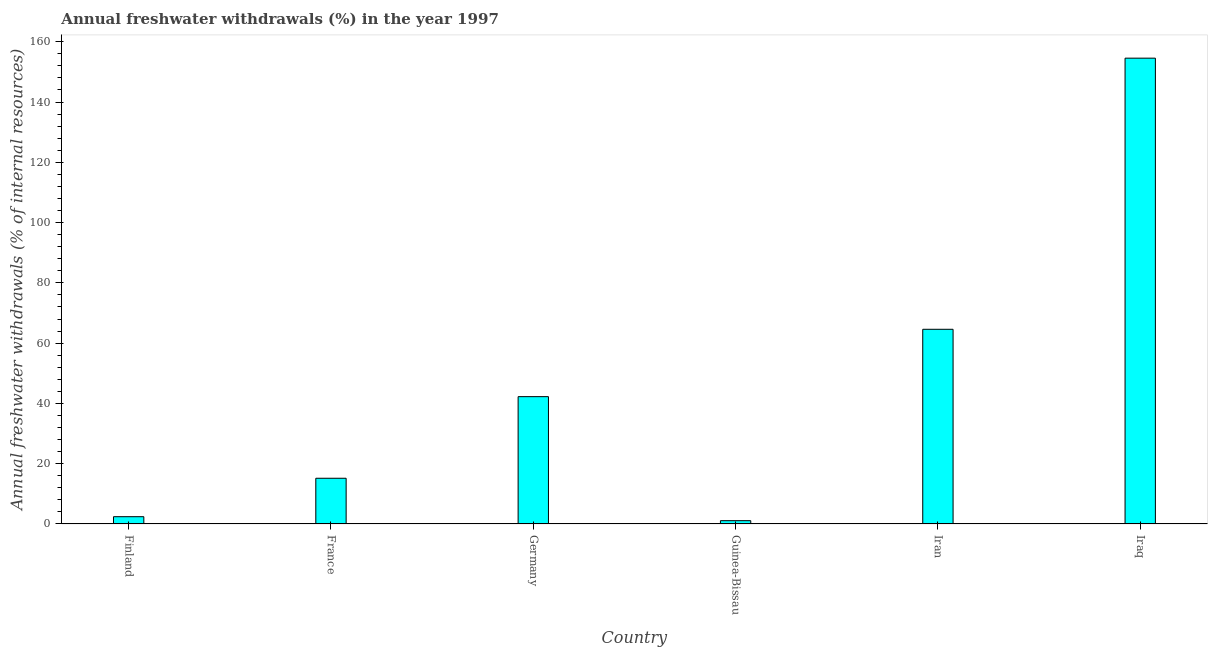Does the graph contain any zero values?
Your answer should be compact. No. Does the graph contain grids?
Provide a succinct answer. No. What is the title of the graph?
Make the answer very short. Annual freshwater withdrawals (%) in the year 1997. What is the label or title of the Y-axis?
Your answer should be compact. Annual freshwater withdrawals (% of internal resources). What is the annual freshwater withdrawals in France?
Provide a short and direct response. 15.17. Across all countries, what is the maximum annual freshwater withdrawals?
Make the answer very short. 154.55. Across all countries, what is the minimum annual freshwater withdrawals?
Ensure brevity in your answer.  1.09. In which country was the annual freshwater withdrawals maximum?
Offer a very short reply. Iraq. In which country was the annual freshwater withdrawals minimum?
Ensure brevity in your answer.  Guinea-Bissau. What is the sum of the annual freshwater withdrawals?
Provide a short and direct response. 280.06. What is the difference between the annual freshwater withdrawals in France and Guinea-Bissau?
Make the answer very short. 14.08. What is the average annual freshwater withdrawals per country?
Your answer should be compact. 46.68. What is the median annual freshwater withdrawals?
Offer a very short reply. 28.71. What is the ratio of the annual freshwater withdrawals in Finland to that in Iran?
Provide a succinct answer. 0.04. Is the difference between the annual freshwater withdrawals in Germany and Guinea-Bissau greater than the difference between any two countries?
Your answer should be compact. No. What is the difference between the highest and the second highest annual freshwater withdrawals?
Offer a very short reply. 89.95. What is the difference between the highest and the lowest annual freshwater withdrawals?
Your answer should be very brief. 153.45. In how many countries, is the annual freshwater withdrawals greater than the average annual freshwater withdrawals taken over all countries?
Your response must be concise. 2. How many bars are there?
Ensure brevity in your answer.  6. What is the difference between two consecutive major ticks on the Y-axis?
Give a very brief answer. 20. Are the values on the major ticks of Y-axis written in scientific E-notation?
Provide a short and direct response. No. What is the Annual freshwater withdrawals (% of internal resources) of Finland?
Provide a short and direct response. 2.42. What is the Annual freshwater withdrawals (% of internal resources) of France?
Keep it short and to the point. 15.17. What is the Annual freshwater withdrawals (% of internal resources) in Germany?
Ensure brevity in your answer.  42.24. What is the Annual freshwater withdrawals (% of internal resources) of Guinea-Bissau?
Give a very brief answer. 1.09. What is the Annual freshwater withdrawals (% of internal resources) of Iran?
Provide a succinct answer. 64.59. What is the Annual freshwater withdrawals (% of internal resources) of Iraq?
Make the answer very short. 154.55. What is the difference between the Annual freshwater withdrawals (% of internal resources) in Finland and France?
Offer a very short reply. -12.75. What is the difference between the Annual freshwater withdrawals (% of internal resources) in Finland and Germany?
Offer a very short reply. -39.83. What is the difference between the Annual freshwater withdrawals (% of internal resources) in Finland and Guinea-Bissau?
Ensure brevity in your answer.  1.32. What is the difference between the Annual freshwater withdrawals (% of internal resources) in Finland and Iran?
Your answer should be compact. -62.17. What is the difference between the Annual freshwater withdrawals (% of internal resources) in Finland and Iraq?
Provide a succinct answer. -152.13. What is the difference between the Annual freshwater withdrawals (% of internal resources) in France and Germany?
Keep it short and to the point. -27.07. What is the difference between the Annual freshwater withdrawals (% of internal resources) in France and Guinea-Bissau?
Make the answer very short. 14.08. What is the difference between the Annual freshwater withdrawals (% of internal resources) in France and Iran?
Keep it short and to the point. -49.42. What is the difference between the Annual freshwater withdrawals (% of internal resources) in France and Iraq?
Offer a very short reply. -139.38. What is the difference between the Annual freshwater withdrawals (% of internal resources) in Germany and Guinea-Bissau?
Your answer should be very brief. 41.15. What is the difference between the Annual freshwater withdrawals (% of internal resources) in Germany and Iran?
Make the answer very short. -22.35. What is the difference between the Annual freshwater withdrawals (% of internal resources) in Germany and Iraq?
Your response must be concise. -112.3. What is the difference between the Annual freshwater withdrawals (% of internal resources) in Guinea-Bissau and Iran?
Provide a succinct answer. -63.5. What is the difference between the Annual freshwater withdrawals (% of internal resources) in Guinea-Bissau and Iraq?
Make the answer very short. -153.45. What is the difference between the Annual freshwater withdrawals (% of internal resources) in Iran and Iraq?
Provide a succinct answer. -89.95. What is the ratio of the Annual freshwater withdrawals (% of internal resources) in Finland to that in France?
Your response must be concise. 0.16. What is the ratio of the Annual freshwater withdrawals (% of internal resources) in Finland to that in Germany?
Give a very brief answer. 0.06. What is the ratio of the Annual freshwater withdrawals (% of internal resources) in Finland to that in Guinea-Bissau?
Keep it short and to the point. 2.21. What is the ratio of the Annual freshwater withdrawals (% of internal resources) in Finland to that in Iran?
Provide a succinct answer. 0.04. What is the ratio of the Annual freshwater withdrawals (% of internal resources) in Finland to that in Iraq?
Your answer should be very brief. 0.02. What is the ratio of the Annual freshwater withdrawals (% of internal resources) in France to that in Germany?
Offer a terse response. 0.36. What is the ratio of the Annual freshwater withdrawals (% of internal resources) in France to that in Guinea-Bissau?
Provide a succinct answer. 13.87. What is the ratio of the Annual freshwater withdrawals (% of internal resources) in France to that in Iran?
Keep it short and to the point. 0.23. What is the ratio of the Annual freshwater withdrawals (% of internal resources) in France to that in Iraq?
Make the answer very short. 0.1. What is the ratio of the Annual freshwater withdrawals (% of internal resources) in Germany to that in Guinea-Bissau?
Make the answer very short. 38.62. What is the ratio of the Annual freshwater withdrawals (% of internal resources) in Germany to that in Iran?
Make the answer very short. 0.65. What is the ratio of the Annual freshwater withdrawals (% of internal resources) in Germany to that in Iraq?
Your answer should be compact. 0.27. What is the ratio of the Annual freshwater withdrawals (% of internal resources) in Guinea-Bissau to that in Iran?
Provide a succinct answer. 0.02. What is the ratio of the Annual freshwater withdrawals (% of internal resources) in Guinea-Bissau to that in Iraq?
Offer a terse response. 0.01. What is the ratio of the Annual freshwater withdrawals (% of internal resources) in Iran to that in Iraq?
Your response must be concise. 0.42. 